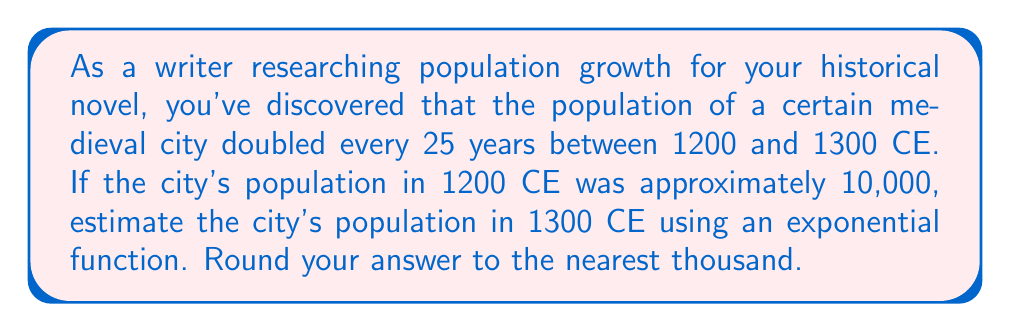Help me with this question. To solve this problem, we'll use an exponential function to model the population growth. Let's break it down step-by-step:

1) The general form of an exponential growth function is:
   $$P(t) = P_0 \cdot (1+r)^t$$
   where $P(t)$ is the population at time $t$, $P_0$ is the initial population, $r$ is the growth rate, and $t$ is the number of time periods.

2) We know:
   - Initial population $P_0 = 10,000$ (in 1200 CE)
   - The population doubles every 25 years
   - We want to find the population after 100 years (from 1200 to 1300 CE)

3) To find the growth rate $r$, we can use the doubling time:
   $$2 = (1+r)^{25}$$
   $$\sqrt[25]{2} = 1+r$$
   $$r = \sqrt[25]{2} - 1 \approx 0.0281 \text{ or } 2.81\% \text{ per year}$$

4) Now we can set up our exponential function:
   $$P(t) = 10,000 \cdot (1.0281)^t$$

5) We want to find $P(100)$ since we're looking at a 100-year period:
   $$P(100) = 10,000 \cdot (1.0281)^{100}$$

6) Calculate:
   $$P(100) = 10,000 \cdot 16.4439 = 164,439$$

7) Rounding to the nearest thousand:
   $$P(100) \approx 164,000$$
Answer: The estimated population of the city in 1300 CE is approximately 164,000. 